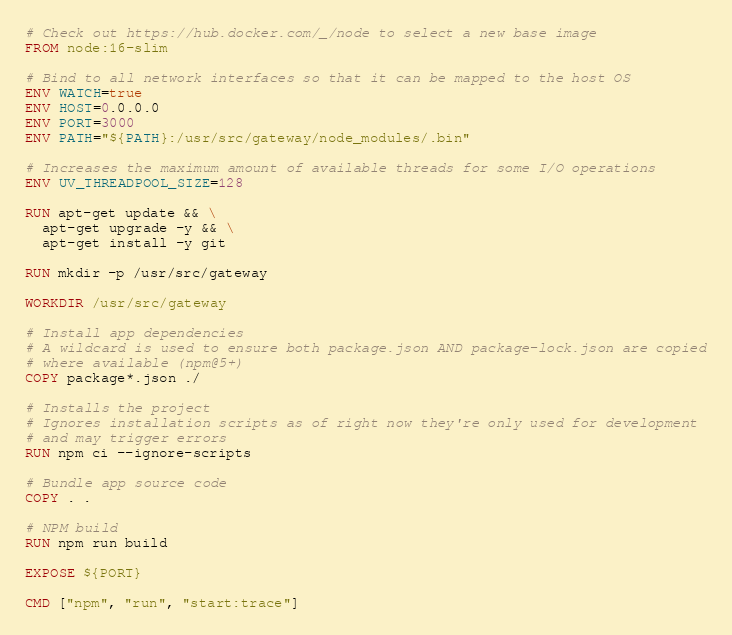<code> <loc_0><loc_0><loc_500><loc_500><_Dockerfile_># Check out https://hub.docker.com/_/node to select a new base image
FROM node:16-slim

# Bind to all network interfaces so that it can be mapped to the host OS
ENV WATCH=true
ENV HOST=0.0.0.0
ENV PORT=3000
ENV PATH="${PATH}:/usr/src/gateway/node_modules/.bin"

# Increases the maximum amount of available threads for some I/O operations
ENV UV_THREADPOOL_SIZE=128

RUN apt-get update && \
  apt-get upgrade -y && \
  apt-get install -y git

RUN mkdir -p /usr/src/gateway

WORKDIR /usr/src/gateway

# Install app dependencies
# A wildcard is used to ensure both package.json AND package-lock.json are copied
# where available (npm@5+)
COPY package*.json ./

# Installs the project
# Ignores installation scripts as of right now they're only used for development
# and may trigger errors
RUN npm ci --ignore-scripts

# Bundle app source code
COPY . .

# NPM build
RUN npm run build

EXPOSE ${PORT}

CMD ["npm", "run", "start:trace"]
</code> 